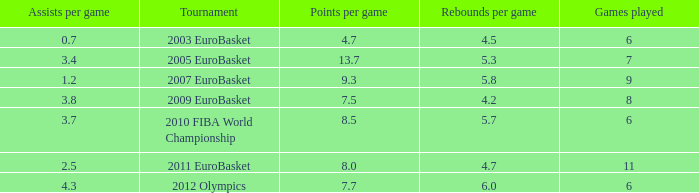Can you give me this table as a dict? {'header': ['Assists per game', 'Tournament', 'Points per game', 'Rebounds per game', 'Games played'], 'rows': [['0.7', '2003 EuroBasket', '4.7', '4.5', '6'], ['3.4', '2005 EuroBasket', '13.7', '5.3', '7'], ['1.2', '2007 EuroBasket', '9.3', '5.8', '9'], ['3.8', '2009 EuroBasket', '7.5', '4.2', '8'], ['3.7', '2010 FIBA World Championship', '8.5', '5.7', '6'], ['2.5', '2011 EuroBasket', '8.0', '4.7', '11'], ['4.3', '2012 Olympics', '7.7', '6.0', '6']]} How many games played have 4.7 as points per game? 6.0. 